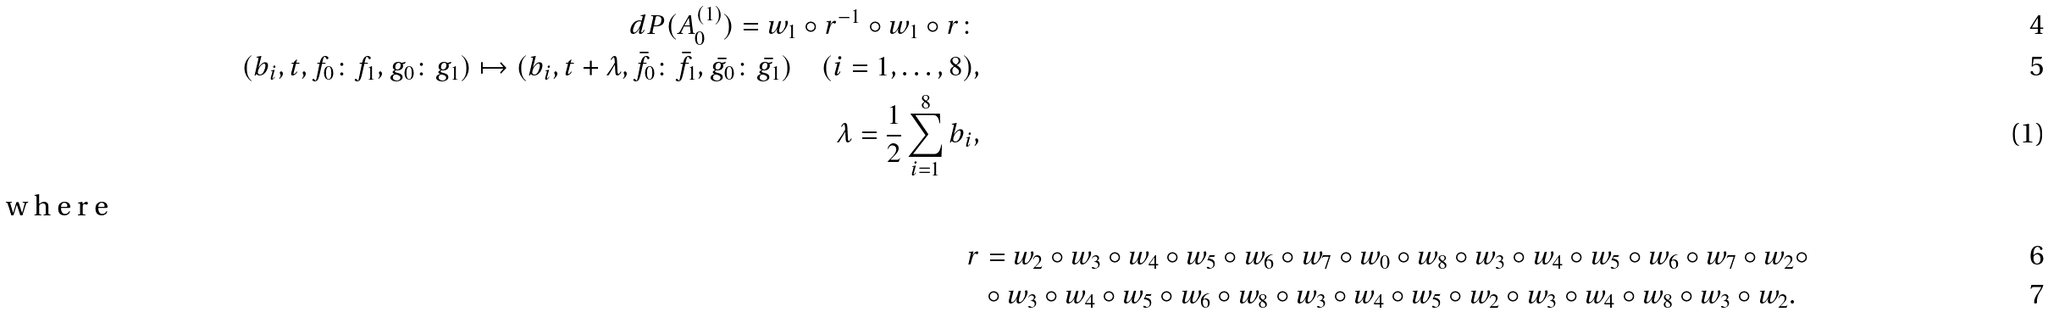Convert formula to latex. <formula><loc_0><loc_0><loc_500><loc_500>d P ( A _ { 0 } ^ { ( 1 ) } ) = w _ { 1 } \circ r ^ { - 1 } \circ w _ { 1 } \circ r \colon \\ ( b _ { i } , t , f _ { 0 } \colon f _ { 1 } , g _ { 0 } \colon g _ { 1 } ) \mapsto ( b _ { i } , t + \lambda , \bar { f _ { 0 } } \colon \bar { f _ { 1 } } , \bar { g _ { 0 } } \colon \bar { g _ { 1 } } ) \quad ( i = 1 , \dots , 8 ) , \\ \lambda = \frac { 1 } { 2 } \sum _ { i = 1 } ^ { 8 } b _ { i } , \intertext { w h e r e } r & = w _ { 2 } \circ w _ { 3 } \circ w _ { 4 } \circ w _ { 5 } \circ w _ { 6 } \circ w _ { 7 } \circ w _ { 0 } \circ w _ { 8 } \circ w _ { 3 } \circ w _ { 4 } \circ w _ { 5 } \circ w _ { 6 } \circ w _ { 7 } \circ w _ { 2 } \circ \\ & \circ w _ { 3 } \circ w _ { 4 } \circ w _ { 5 } \circ w _ { 6 } \circ w _ { 8 } \circ w _ { 3 } \circ w _ { 4 } \circ w _ { 5 } \circ w _ { 2 } \circ w _ { 3 } \circ w _ { 4 } \circ w _ { 8 } \circ w _ { 3 } \circ w _ { 2 } .</formula> 